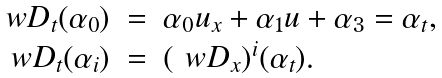<formula> <loc_0><loc_0><loc_500><loc_500>\begin{array} { r c l } \ w D _ { t } ( \alpha _ { 0 } ) & = & \alpha _ { 0 } u _ { x } + \alpha _ { 1 } u + \alpha _ { 3 } = \alpha _ { t } , \\ \ w D _ { t } ( \alpha _ { i } ) & = & ( \ w D _ { x } ) ^ { i } ( \alpha _ { t } ) . \end{array}</formula> 